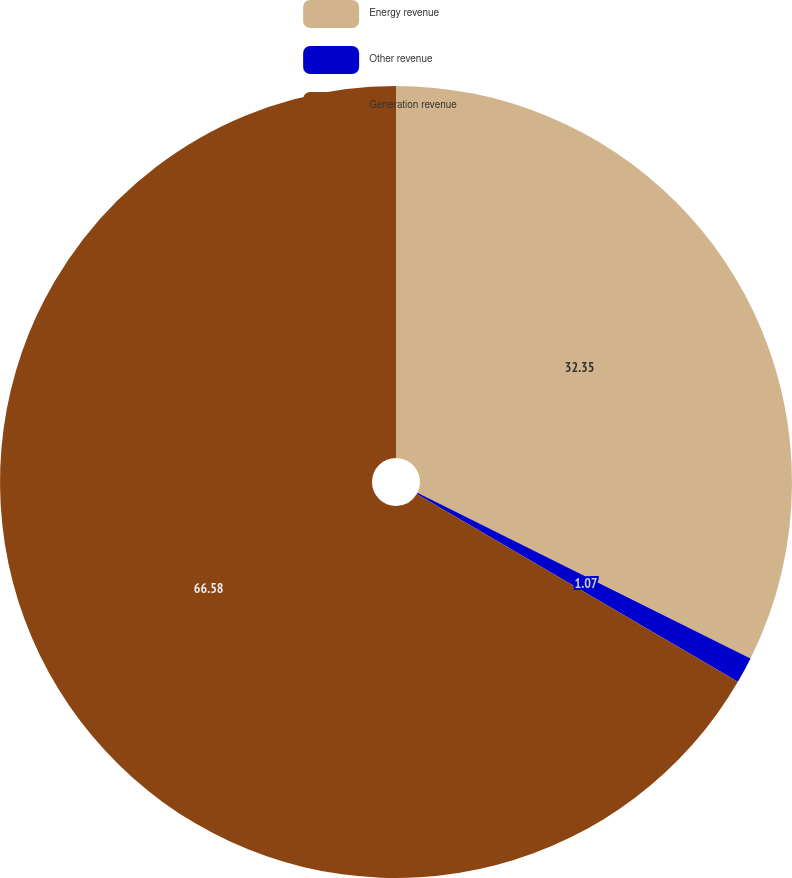<chart> <loc_0><loc_0><loc_500><loc_500><pie_chart><fcel>Energy revenue<fcel>Other revenue<fcel>Generation revenue<nl><fcel>32.35%<fcel>1.07%<fcel>66.58%<nl></chart> 